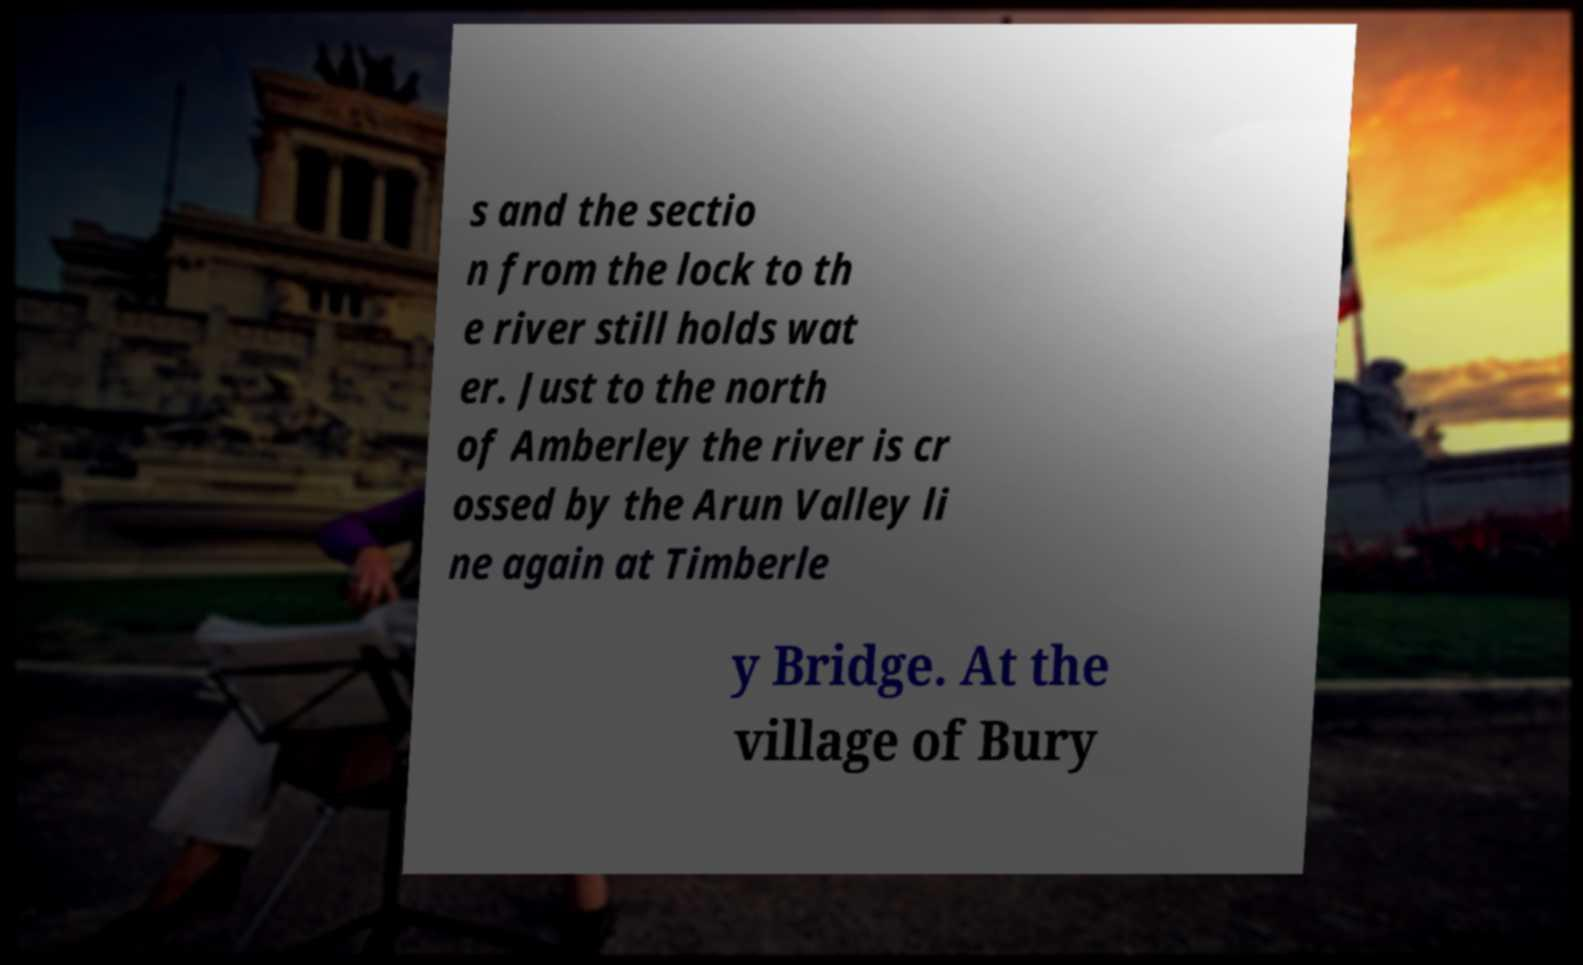There's text embedded in this image that I need extracted. Can you transcribe it verbatim? s and the sectio n from the lock to th e river still holds wat er. Just to the north of Amberley the river is cr ossed by the Arun Valley li ne again at Timberle y Bridge. At the village of Bury 